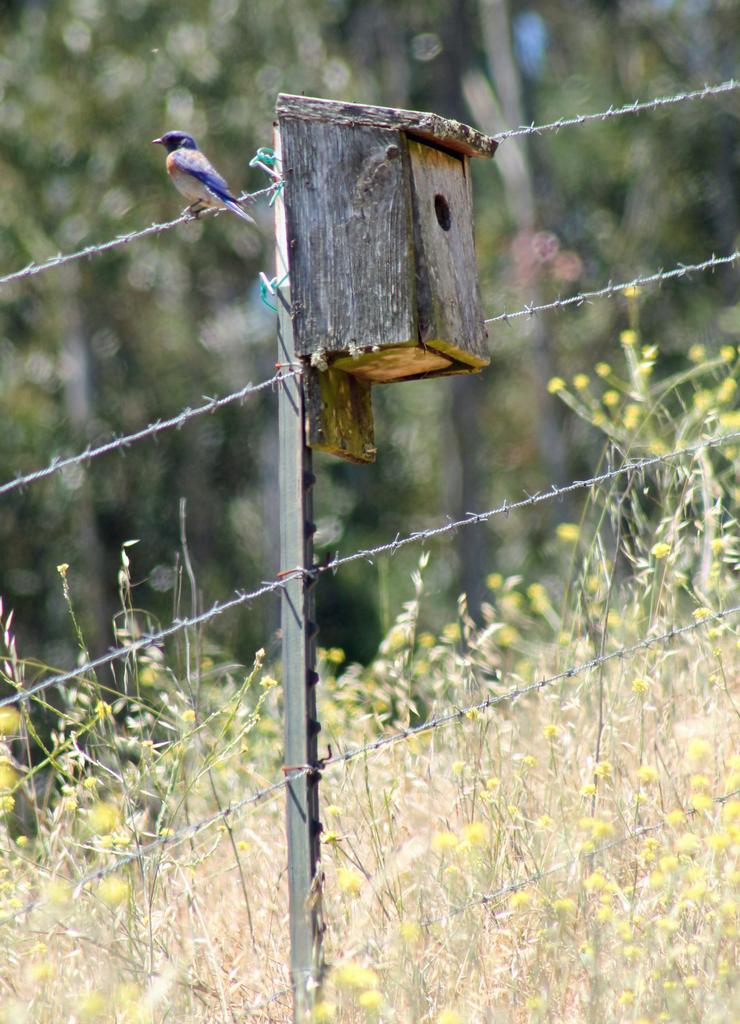What structure is visible in the image? There is a birdhouse in the image. What object can be seen near the birdhouse? There is a rod in the image. Where is the bird located in the image? The bird is on the fence in the image. What can be seen in the background of the image? There are plants and trees in the background of the image. What type of sock is the boy wearing in the image? There is no boy present in the image, so it is not possible to determine what type of sock he might be wearing. 